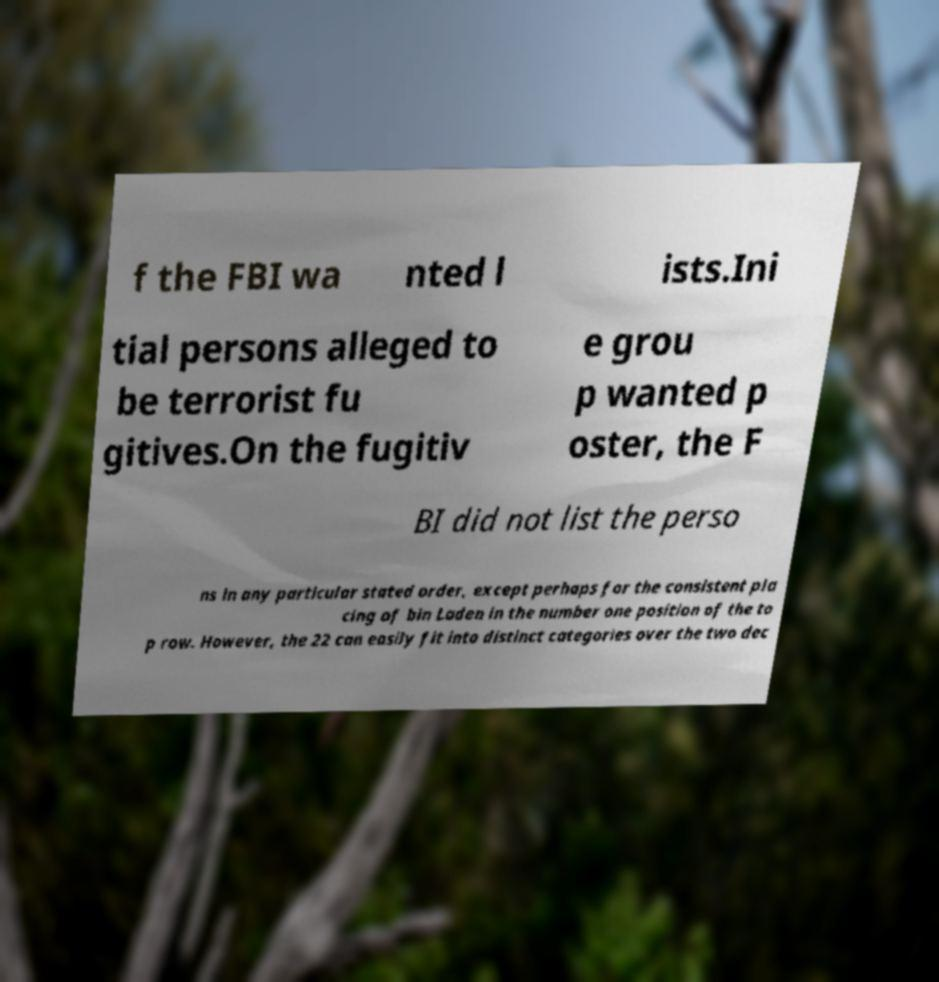I need the written content from this picture converted into text. Can you do that? f the FBI wa nted l ists.Ini tial persons alleged to be terrorist fu gitives.On the fugitiv e grou p wanted p oster, the F BI did not list the perso ns in any particular stated order, except perhaps for the consistent pla cing of bin Laden in the number one position of the to p row. However, the 22 can easily fit into distinct categories over the two dec 